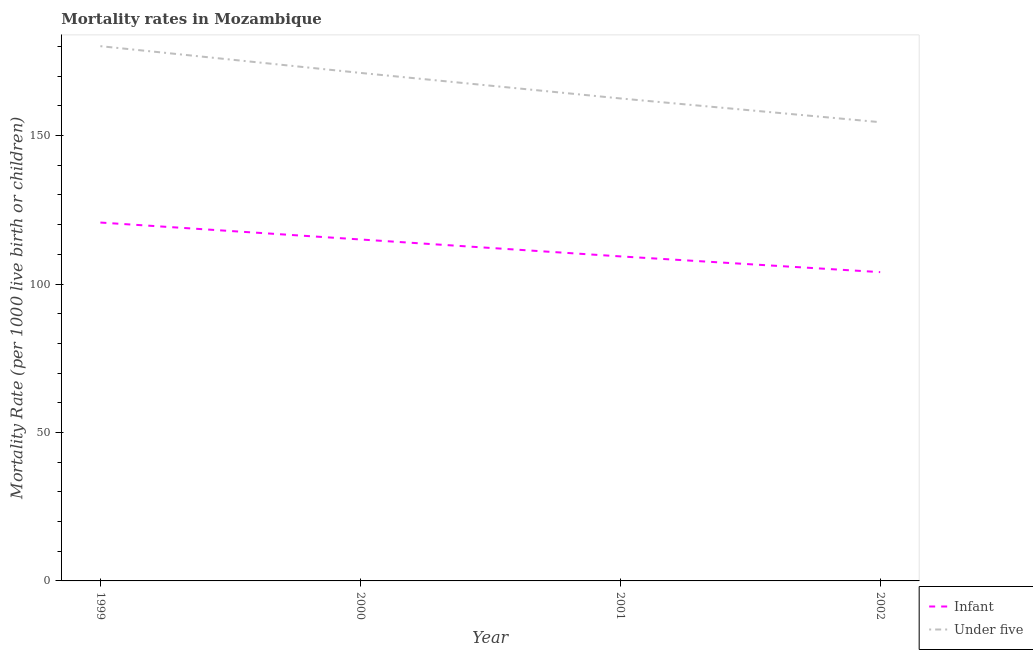How many different coloured lines are there?
Your response must be concise. 2. Does the line corresponding to infant mortality rate intersect with the line corresponding to under-5 mortality rate?
Your answer should be compact. No. What is the under-5 mortality rate in 2001?
Your answer should be very brief. 162.5. Across all years, what is the maximum infant mortality rate?
Offer a very short reply. 120.7. Across all years, what is the minimum infant mortality rate?
Offer a very short reply. 104. In which year was the under-5 mortality rate maximum?
Make the answer very short. 1999. In which year was the infant mortality rate minimum?
Your answer should be very brief. 2002. What is the total infant mortality rate in the graph?
Give a very brief answer. 449. What is the difference between the under-5 mortality rate in 2001 and that in 2002?
Give a very brief answer. 8. What is the difference between the under-5 mortality rate in 2002 and the infant mortality rate in 2000?
Your response must be concise. 39.5. What is the average under-5 mortality rate per year?
Offer a terse response. 167.05. In the year 2002, what is the difference between the under-5 mortality rate and infant mortality rate?
Your response must be concise. 50.5. In how many years, is the under-5 mortality rate greater than 130?
Ensure brevity in your answer.  4. What is the ratio of the infant mortality rate in 1999 to that in 2000?
Your response must be concise. 1.05. Is the infant mortality rate in 1999 less than that in 2002?
Provide a short and direct response. No. What is the difference between the highest and the second highest under-5 mortality rate?
Ensure brevity in your answer.  9. What is the difference between the highest and the lowest infant mortality rate?
Keep it short and to the point. 16.7. In how many years, is the infant mortality rate greater than the average infant mortality rate taken over all years?
Your answer should be very brief. 2. Is the infant mortality rate strictly greater than the under-5 mortality rate over the years?
Offer a terse response. No. Is the infant mortality rate strictly less than the under-5 mortality rate over the years?
Make the answer very short. Yes. Are the values on the major ticks of Y-axis written in scientific E-notation?
Give a very brief answer. No. Where does the legend appear in the graph?
Keep it short and to the point. Bottom right. How many legend labels are there?
Provide a short and direct response. 2. What is the title of the graph?
Your answer should be compact. Mortality rates in Mozambique. What is the label or title of the Y-axis?
Your answer should be very brief. Mortality Rate (per 1000 live birth or children). What is the Mortality Rate (per 1000 live birth or children) of Infant in 1999?
Provide a succinct answer. 120.7. What is the Mortality Rate (per 1000 live birth or children) of Under five in 1999?
Keep it short and to the point. 180.1. What is the Mortality Rate (per 1000 live birth or children) of Infant in 2000?
Make the answer very short. 115. What is the Mortality Rate (per 1000 live birth or children) of Under five in 2000?
Provide a short and direct response. 171.1. What is the Mortality Rate (per 1000 live birth or children) in Infant in 2001?
Give a very brief answer. 109.3. What is the Mortality Rate (per 1000 live birth or children) in Under five in 2001?
Your response must be concise. 162.5. What is the Mortality Rate (per 1000 live birth or children) in Infant in 2002?
Give a very brief answer. 104. What is the Mortality Rate (per 1000 live birth or children) in Under five in 2002?
Offer a very short reply. 154.5. Across all years, what is the maximum Mortality Rate (per 1000 live birth or children) in Infant?
Keep it short and to the point. 120.7. Across all years, what is the maximum Mortality Rate (per 1000 live birth or children) in Under five?
Your response must be concise. 180.1. Across all years, what is the minimum Mortality Rate (per 1000 live birth or children) in Infant?
Provide a succinct answer. 104. Across all years, what is the minimum Mortality Rate (per 1000 live birth or children) of Under five?
Ensure brevity in your answer.  154.5. What is the total Mortality Rate (per 1000 live birth or children) in Infant in the graph?
Your answer should be compact. 449. What is the total Mortality Rate (per 1000 live birth or children) in Under five in the graph?
Give a very brief answer. 668.2. What is the difference between the Mortality Rate (per 1000 live birth or children) in Infant in 1999 and that in 2000?
Your answer should be compact. 5.7. What is the difference between the Mortality Rate (per 1000 live birth or children) in Infant in 1999 and that in 2001?
Keep it short and to the point. 11.4. What is the difference between the Mortality Rate (per 1000 live birth or children) in Under five in 1999 and that in 2001?
Offer a terse response. 17.6. What is the difference between the Mortality Rate (per 1000 live birth or children) of Under five in 1999 and that in 2002?
Provide a short and direct response. 25.6. What is the difference between the Mortality Rate (per 1000 live birth or children) of Infant in 2000 and that in 2002?
Ensure brevity in your answer.  11. What is the difference between the Mortality Rate (per 1000 live birth or children) in Infant in 1999 and the Mortality Rate (per 1000 live birth or children) in Under five in 2000?
Your answer should be compact. -50.4. What is the difference between the Mortality Rate (per 1000 live birth or children) in Infant in 1999 and the Mortality Rate (per 1000 live birth or children) in Under five in 2001?
Keep it short and to the point. -41.8. What is the difference between the Mortality Rate (per 1000 live birth or children) of Infant in 1999 and the Mortality Rate (per 1000 live birth or children) of Under five in 2002?
Provide a succinct answer. -33.8. What is the difference between the Mortality Rate (per 1000 live birth or children) of Infant in 2000 and the Mortality Rate (per 1000 live birth or children) of Under five in 2001?
Provide a short and direct response. -47.5. What is the difference between the Mortality Rate (per 1000 live birth or children) in Infant in 2000 and the Mortality Rate (per 1000 live birth or children) in Under five in 2002?
Make the answer very short. -39.5. What is the difference between the Mortality Rate (per 1000 live birth or children) of Infant in 2001 and the Mortality Rate (per 1000 live birth or children) of Under five in 2002?
Give a very brief answer. -45.2. What is the average Mortality Rate (per 1000 live birth or children) in Infant per year?
Your answer should be compact. 112.25. What is the average Mortality Rate (per 1000 live birth or children) in Under five per year?
Keep it short and to the point. 167.05. In the year 1999, what is the difference between the Mortality Rate (per 1000 live birth or children) in Infant and Mortality Rate (per 1000 live birth or children) in Under five?
Offer a very short reply. -59.4. In the year 2000, what is the difference between the Mortality Rate (per 1000 live birth or children) in Infant and Mortality Rate (per 1000 live birth or children) in Under five?
Provide a short and direct response. -56.1. In the year 2001, what is the difference between the Mortality Rate (per 1000 live birth or children) of Infant and Mortality Rate (per 1000 live birth or children) of Under five?
Give a very brief answer. -53.2. In the year 2002, what is the difference between the Mortality Rate (per 1000 live birth or children) in Infant and Mortality Rate (per 1000 live birth or children) in Under five?
Your answer should be very brief. -50.5. What is the ratio of the Mortality Rate (per 1000 live birth or children) of Infant in 1999 to that in 2000?
Your response must be concise. 1.05. What is the ratio of the Mortality Rate (per 1000 live birth or children) of Under five in 1999 to that in 2000?
Make the answer very short. 1.05. What is the ratio of the Mortality Rate (per 1000 live birth or children) of Infant in 1999 to that in 2001?
Your answer should be very brief. 1.1. What is the ratio of the Mortality Rate (per 1000 live birth or children) in Under five in 1999 to that in 2001?
Give a very brief answer. 1.11. What is the ratio of the Mortality Rate (per 1000 live birth or children) in Infant in 1999 to that in 2002?
Keep it short and to the point. 1.16. What is the ratio of the Mortality Rate (per 1000 live birth or children) in Under five in 1999 to that in 2002?
Provide a short and direct response. 1.17. What is the ratio of the Mortality Rate (per 1000 live birth or children) in Infant in 2000 to that in 2001?
Your response must be concise. 1.05. What is the ratio of the Mortality Rate (per 1000 live birth or children) in Under five in 2000 to that in 2001?
Keep it short and to the point. 1.05. What is the ratio of the Mortality Rate (per 1000 live birth or children) in Infant in 2000 to that in 2002?
Provide a succinct answer. 1.11. What is the ratio of the Mortality Rate (per 1000 live birth or children) in Under five in 2000 to that in 2002?
Your answer should be very brief. 1.11. What is the ratio of the Mortality Rate (per 1000 live birth or children) in Infant in 2001 to that in 2002?
Make the answer very short. 1.05. What is the ratio of the Mortality Rate (per 1000 live birth or children) in Under five in 2001 to that in 2002?
Your response must be concise. 1.05. What is the difference between the highest and the second highest Mortality Rate (per 1000 live birth or children) of Under five?
Ensure brevity in your answer.  9. What is the difference between the highest and the lowest Mortality Rate (per 1000 live birth or children) in Infant?
Keep it short and to the point. 16.7. What is the difference between the highest and the lowest Mortality Rate (per 1000 live birth or children) in Under five?
Your answer should be very brief. 25.6. 